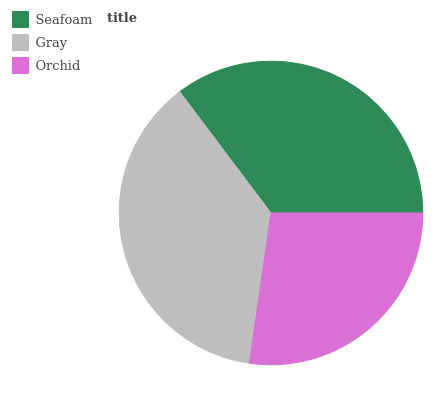Is Orchid the minimum?
Answer yes or no. Yes. Is Gray the maximum?
Answer yes or no. Yes. Is Gray the minimum?
Answer yes or no. No. Is Orchid the maximum?
Answer yes or no. No. Is Gray greater than Orchid?
Answer yes or no. Yes. Is Orchid less than Gray?
Answer yes or no. Yes. Is Orchid greater than Gray?
Answer yes or no. No. Is Gray less than Orchid?
Answer yes or no. No. Is Seafoam the high median?
Answer yes or no. Yes. Is Seafoam the low median?
Answer yes or no. Yes. Is Orchid the high median?
Answer yes or no. No. Is Gray the low median?
Answer yes or no. No. 